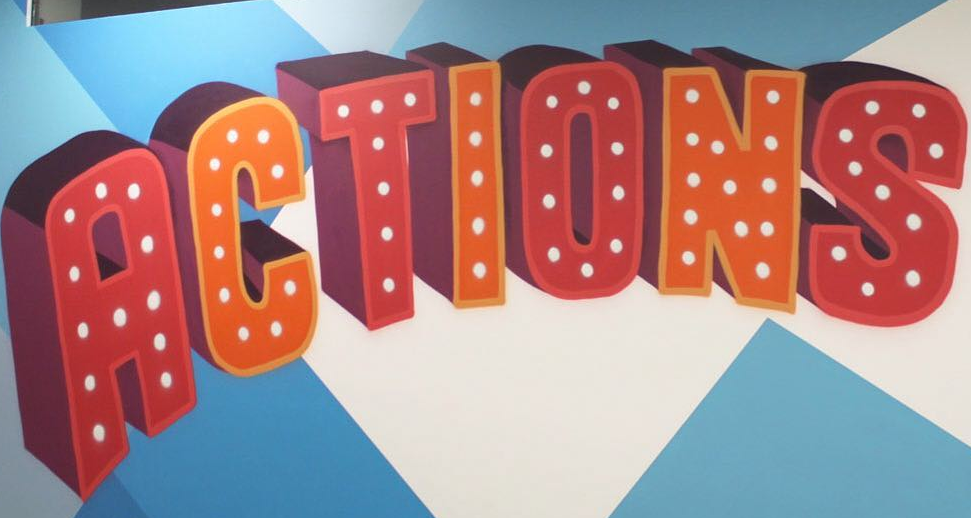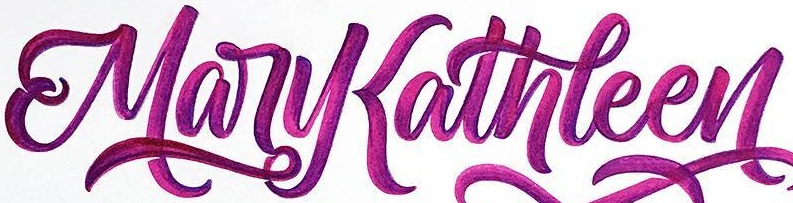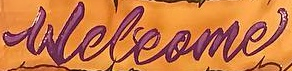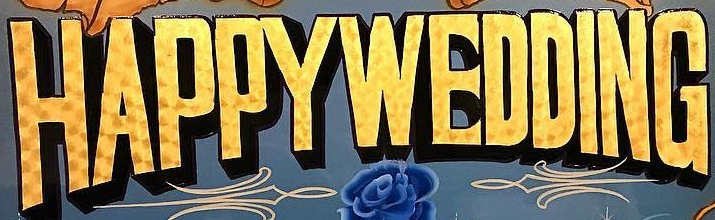What text appears in these images from left to right, separated by a semicolon? ACTIONS; MaryKathleen; Welcome; HAPPYWEDDING 